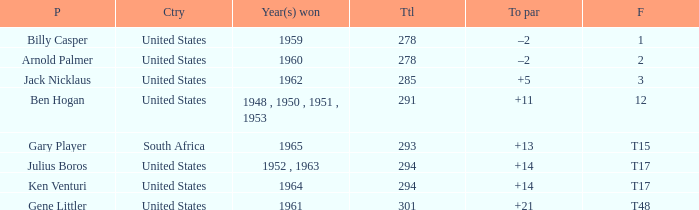What are the winning year(s) when the total is lesser than 285? 1959, 1960. 